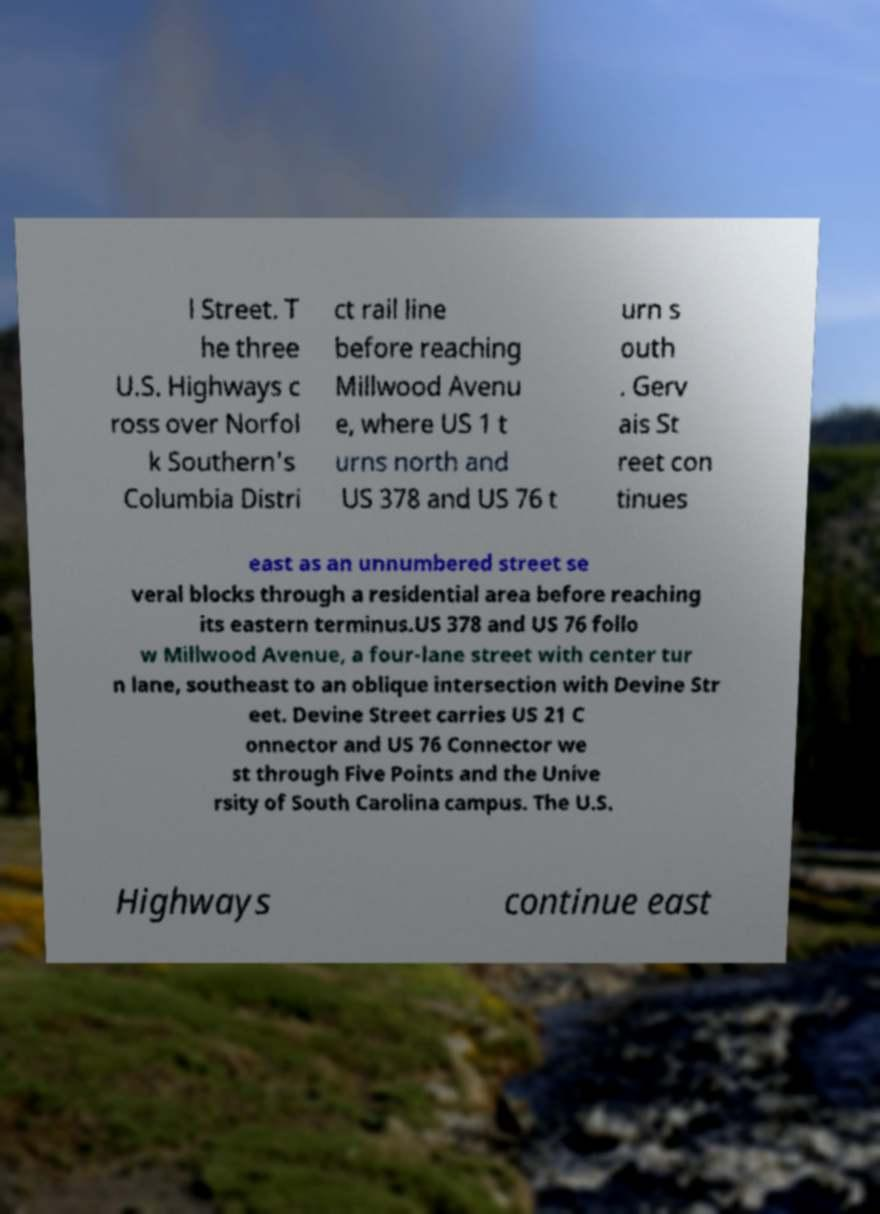Can you accurately transcribe the text from the provided image for me? l Street. T he three U.S. Highways c ross over Norfol k Southern's Columbia Distri ct rail line before reaching Millwood Avenu e, where US 1 t urns north and US 378 and US 76 t urn s outh . Gerv ais St reet con tinues east as an unnumbered street se veral blocks through a residential area before reaching its eastern terminus.US 378 and US 76 follo w Millwood Avenue, a four-lane street with center tur n lane, southeast to an oblique intersection with Devine Str eet. Devine Street carries US 21 C onnector and US 76 Connector we st through Five Points and the Unive rsity of South Carolina campus. The U.S. Highways continue east 